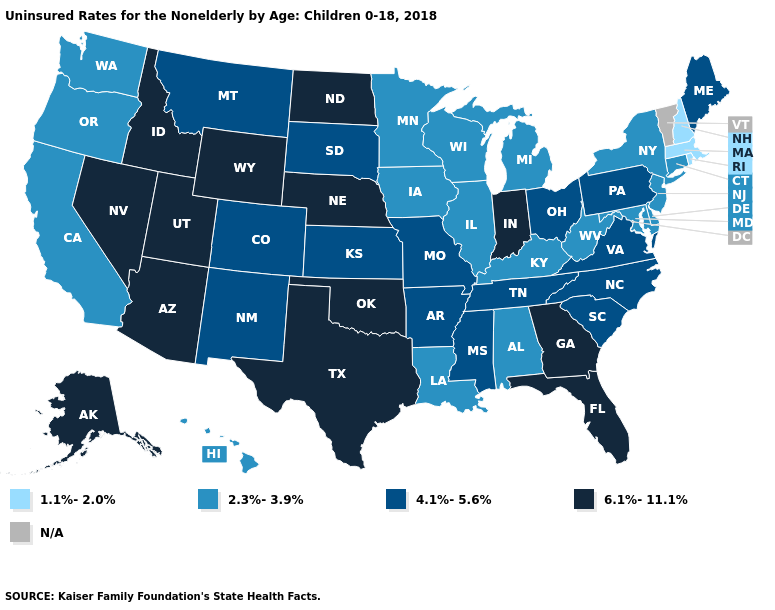What is the value of South Carolina?
Keep it brief. 4.1%-5.6%. What is the value of Tennessee?
Short answer required. 4.1%-5.6%. Name the states that have a value in the range 1.1%-2.0%?
Keep it brief. Massachusetts, New Hampshire, Rhode Island. Name the states that have a value in the range 4.1%-5.6%?
Answer briefly. Arkansas, Colorado, Kansas, Maine, Mississippi, Missouri, Montana, New Mexico, North Carolina, Ohio, Pennsylvania, South Carolina, South Dakota, Tennessee, Virginia. Name the states that have a value in the range 2.3%-3.9%?
Answer briefly. Alabama, California, Connecticut, Delaware, Hawaii, Illinois, Iowa, Kentucky, Louisiana, Maryland, Michigan, Minnesota, New Jersey, New York, Oregon, Washington, West Virginia, Wisconsin. Which states have the lowest value in the Northeast?
Keep it brief. Massachusetts, New Hampshire, Rhode Island. Name the states that have a value in the range 6.1%-11.1%?
Quick response, please. Alaska, Arizona, Florida, Georgia, Idaho, Indiana, Nebraska, Nevada, North Dakota, Oklahoma, Texas, Utah, Wyoming. Does Oregon have the lowest value in the West?
Concise answer only. Yes. Name the states that have a value in the range 2.3%-3.9%?
Answer briefly. Alabama, California, Connecticut, Delaware, Hawaii, Illinois, Iowa, Kentucky, Louisiana, Maryland, Michigan, Minnesota, New Jersey, New York, Oregon, Washington, West Virginia, Wisconsin. Name the states that have a value in the range 4.1%-5.6%?
Write a very short answer. Arkansas, Colorado, Kansas, Maine, Mississippi, Missouri, Montana, New Mexico, North Carolina, Ohio, Pennsylvania, South Carolina, South Dakota, Tennessee, Virginia. Is the legend a continuous bar?
Give a very brief answer. No. What is the value of Connecticut?
Give a very brief answer. 2.3%-3.9%. Which states have the lowest value in the West?
Short answer required. California, Hawaii, Oregon, Washington. 